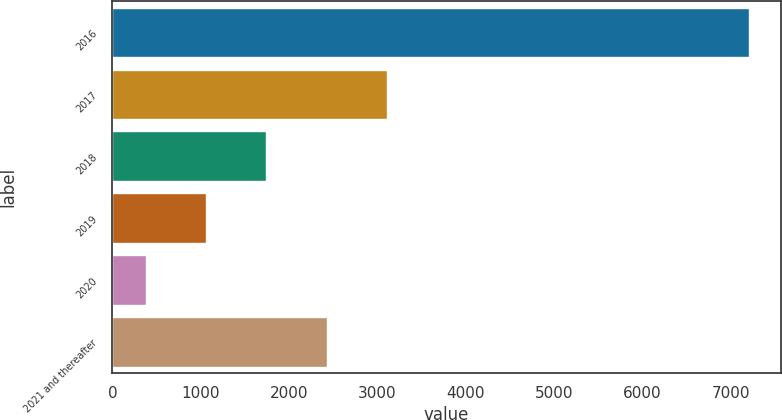<chart> <loc_0><loc_0><loc_500><loc_500><bar_chart><fcel>2016<fcel>2017<fcel>2018<fcel>2019<fcel>2020<fcel>2021 and thereafter<nl><fcel>7202<fcel>3107.6<fcel>1742.8<fcel>1060.4<fcel>378<fcel>2425.2<nl></chart> 